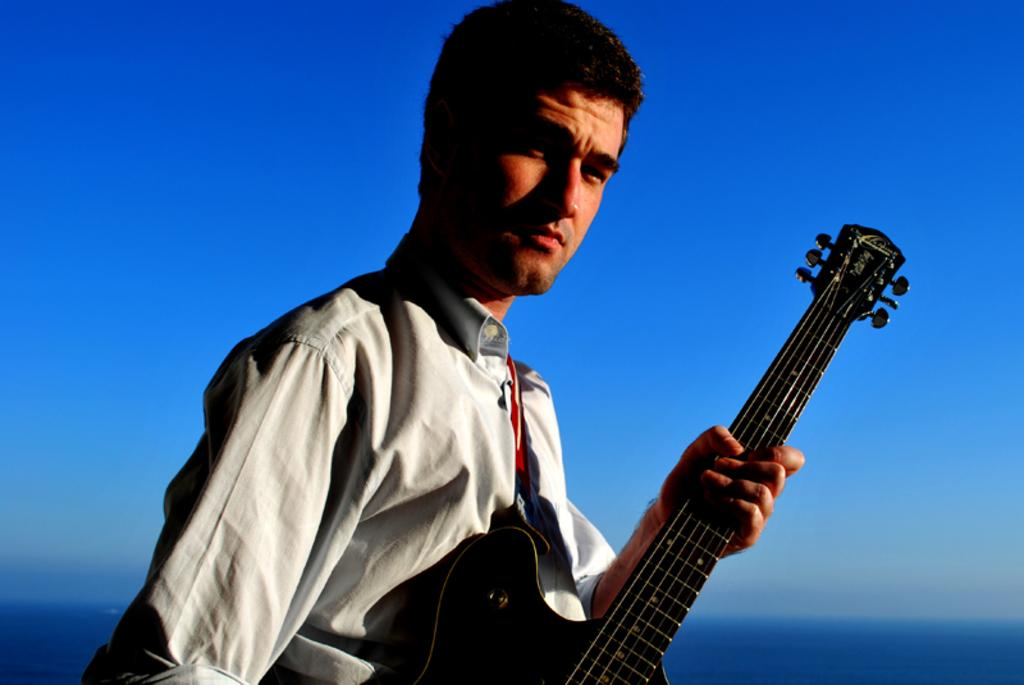Who is present in the image? There is a man in the image. What is the man wearing? The man is wearing a white shirt. What is the man holding in the image? The man is holding a guitar. What can be seen in the background of the image? There is a blue sky visible in the background of the image. What type of glue is the man using to write on the guitar in the image? There is no glue or writing present in the image; the man is simply holding a guitar. 